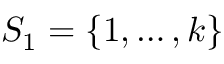<formula> <loc_0><loc_0><loc_500><loc_500>S _ { 1 } = \left \{ 1 , \dots , k \right \}</formula> 